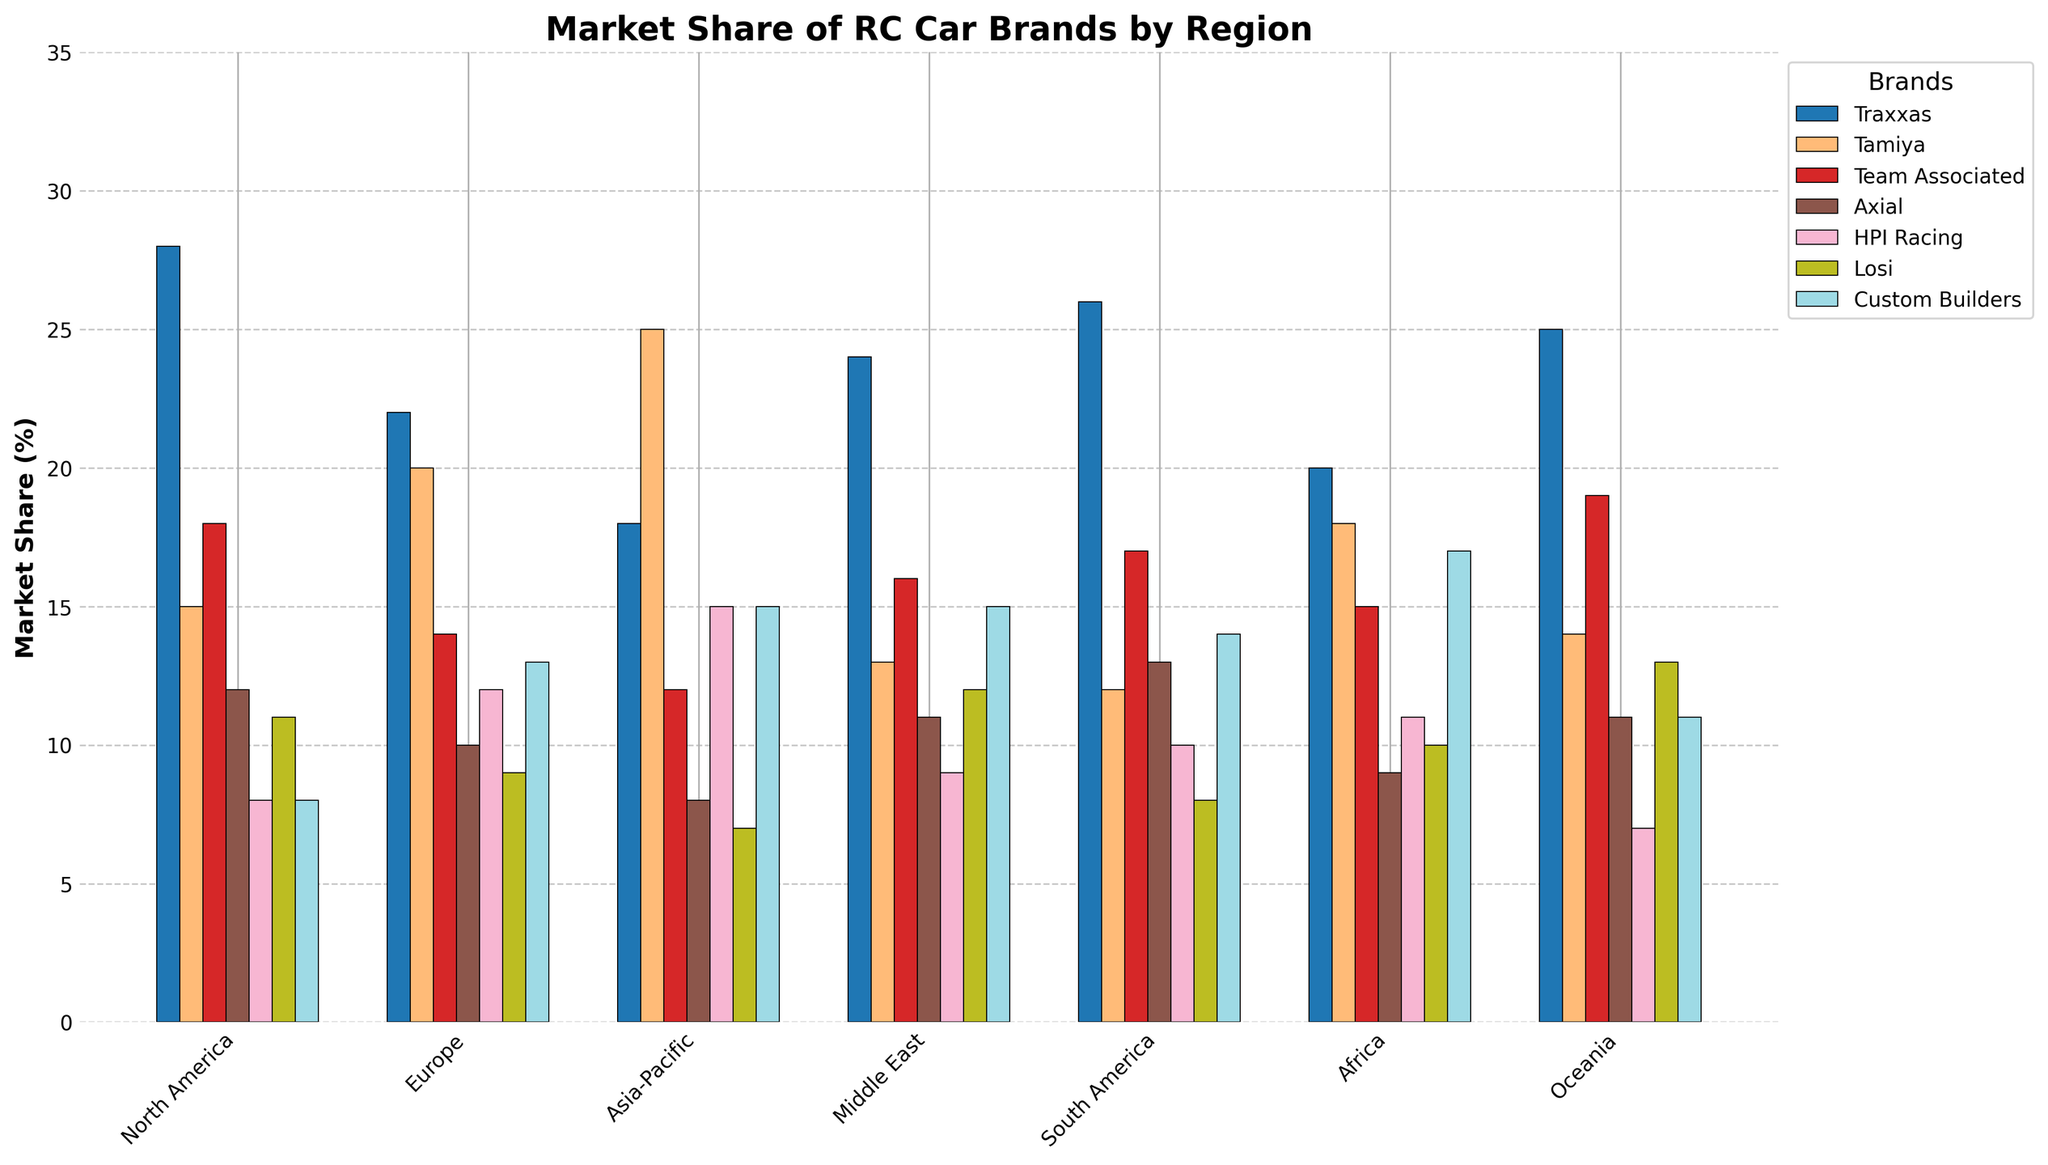What's the market share of Traxxas in North America? Look at the bar for Traxxas in the North America section.
Answer: 28% Which brand has the highest market share in the Asia-Pacific region? Find the tallest bar in the Asia-Pacific region.
Answer: Tamiya What is the difference in market share between Team Associated in Europe and North America? Subtract Team Associated's market share in Europe from its market share in North America.
Answer: 4% Which region shows the highest market share for Custom Builders? Compare all the bars for Custom Builders across different regions and find the tallest one.
Answer: Africa Which brand has consistently more than 10% market share across all regions? Check each brand’s bar in all regions to see which ones are always above 10%.
Answer: Traxxas What is the average market share of Losi across all regions? Sum Losi's market shares across all regions and divide by the number of regions. (11+9+7+12+8+10+13) / 7
Answer: 10% In which regions does Axial have more market share than Tamiya? Compare the heights of bars for Axial and Tamiya in all regions.
Answer: North America, South America, Oceania What is the combined market share of the top three brands in South America? Sum the market shares of the top three brands in South America. (Traxxas, Team Associated, Custom Builders)
Answer: 57% Which brand has the lowest market share in Oceania? Find the shortest bar in the Oceania region.
Answer: HPI Racing Compare the market shares of Traxxas and Custom Builders in North America. Which one is higher and by how much? Look at the bars for Traxxas and Custom Builders in North America and subtract the shorter bar from the taller one.
Answer: Traxxas by 20% 